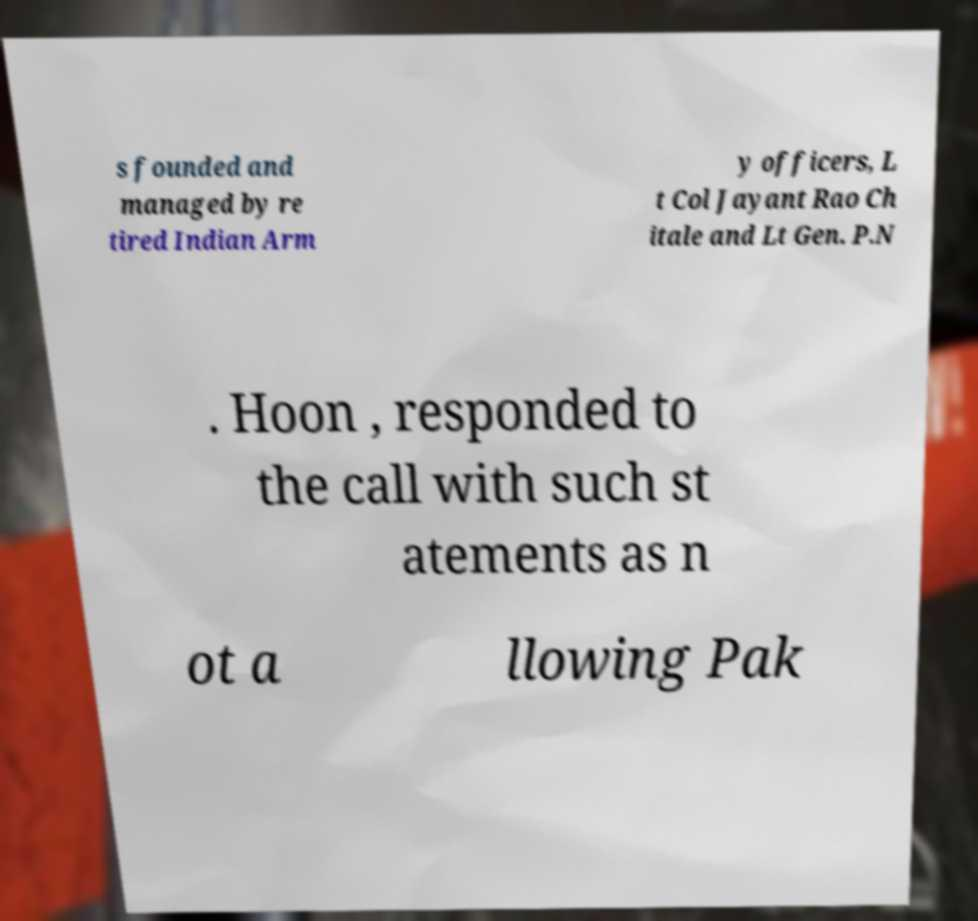Could you assist in decoding the text presented in this image and type it out clearly? s founded and managed by re tired Indian Arm y officers, L t Col Jayant Rao Ch itale and Lt Gen. P.N . Hoon , responded to the call with such st atements as n ot a llowing Pak 